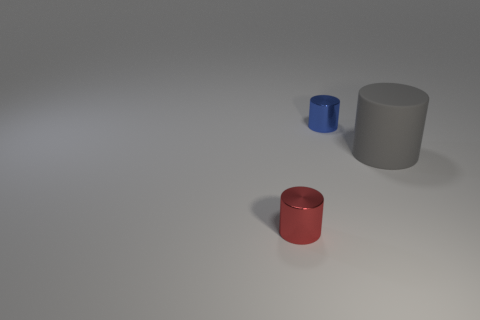Are there fewer big gray cylinders that are in front of the rubber object than big gray rubber cylinders left of the small blue metallic cylinder?
Make the answer very short. No. Is there anything else that has the same shape as the blue object?
Ensure brevity in your answer.  Yes. Does the small blue thing have the same shape as the big object?
Your answer should be very brief. Yes. Is there anything else that is made of the same material as the gray cylinder?
Offer a very short reply. No. What is the size of the red thing?
Offer a very short reply. Small. The object that is both on the right side of the tiny red cylinder and left of the big cylinder is what color?
Offer a very short reply. Blue. Are there more gray matte things than small cylinders?
Your response must be concise. No. What number of objects are either tiny green matte objects or metallic cylinders behind the tiny red cylinder?
Ensure brevity in your answer.  1. Do the red cylinder and the blue shiny object have the same size?
Make the answer very short. Yes. There is a blue metal cylinder; are there any small blue shiny cylinders in front of it?
Offer a terse response. No. 